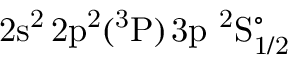<formula> <loc_0><loc_0><loc_500><loc_500>2 s ^ { 2 } \, 2 p ^ { 2 } ( ^ { 3 } P ) \, 3 p ^ { 2 } S _ { 1 / 2 } ^ { \circ }</formula> 